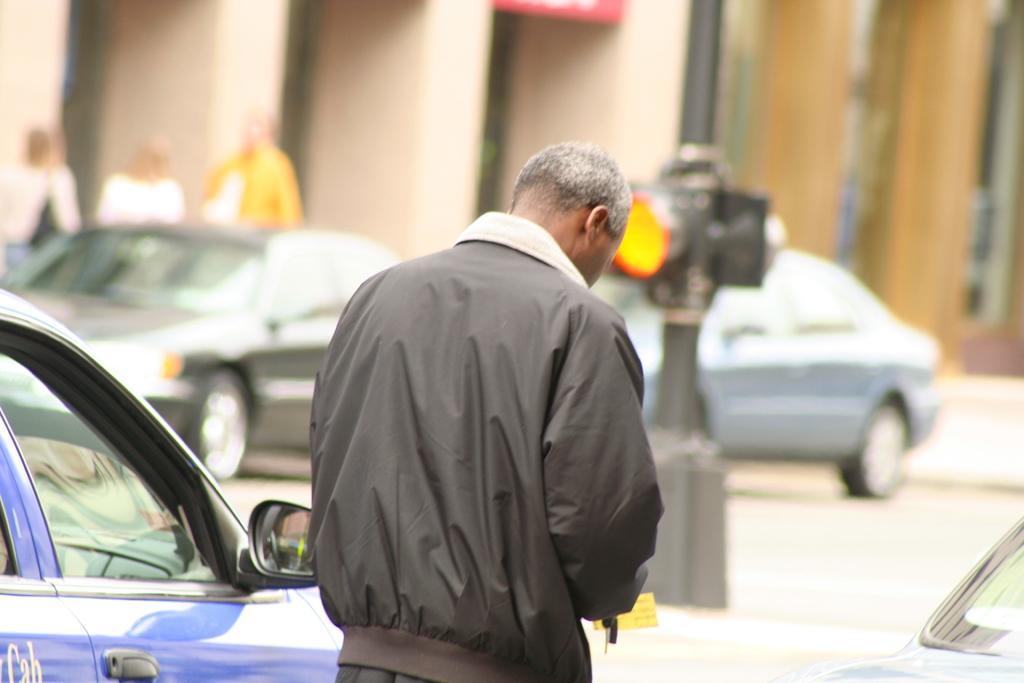Describe this image in one or two sentences. In the center of the image there is a person standing on the road. On the right and left side of the image we can see cars. In the background we can see cars, light, persons and building. 